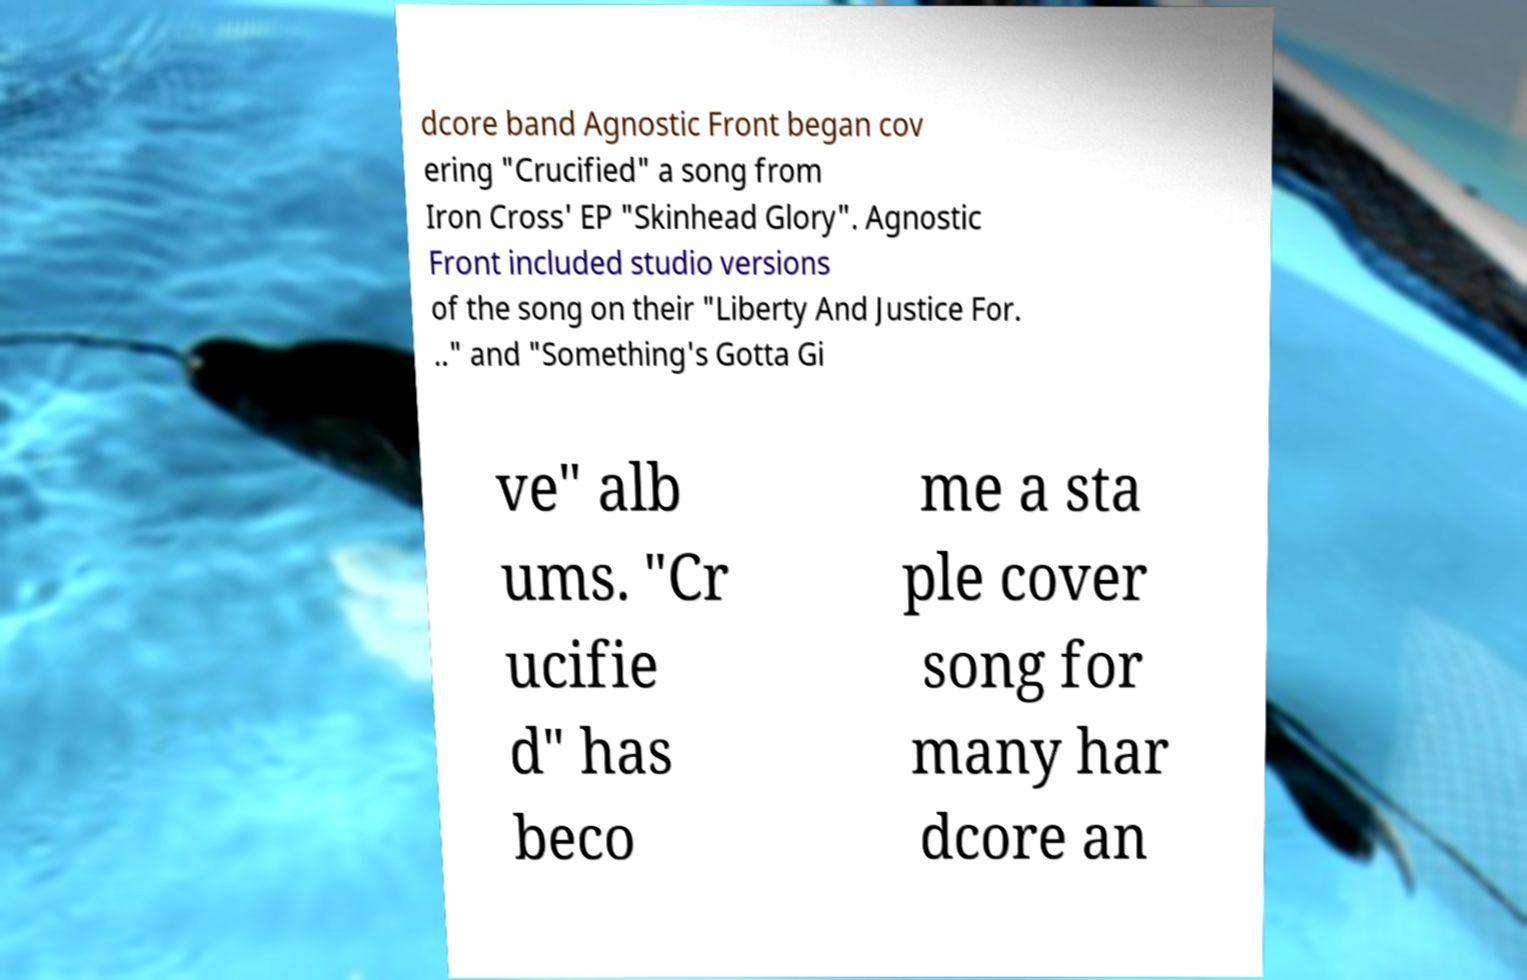Can you accurately transcribe the text from the provided image for me? dcore band Agnostic Front began cov ering "Crucified" a song from Iron Cross' EP "Skinhead Glory". Agnostic Front included studio versions of the song on their "Liberty And Justice For. .." and "Something's Gotta Gi ve" alb ums. "Cr ucifie d" has beco me a sta ple cover song for many har dcore an 